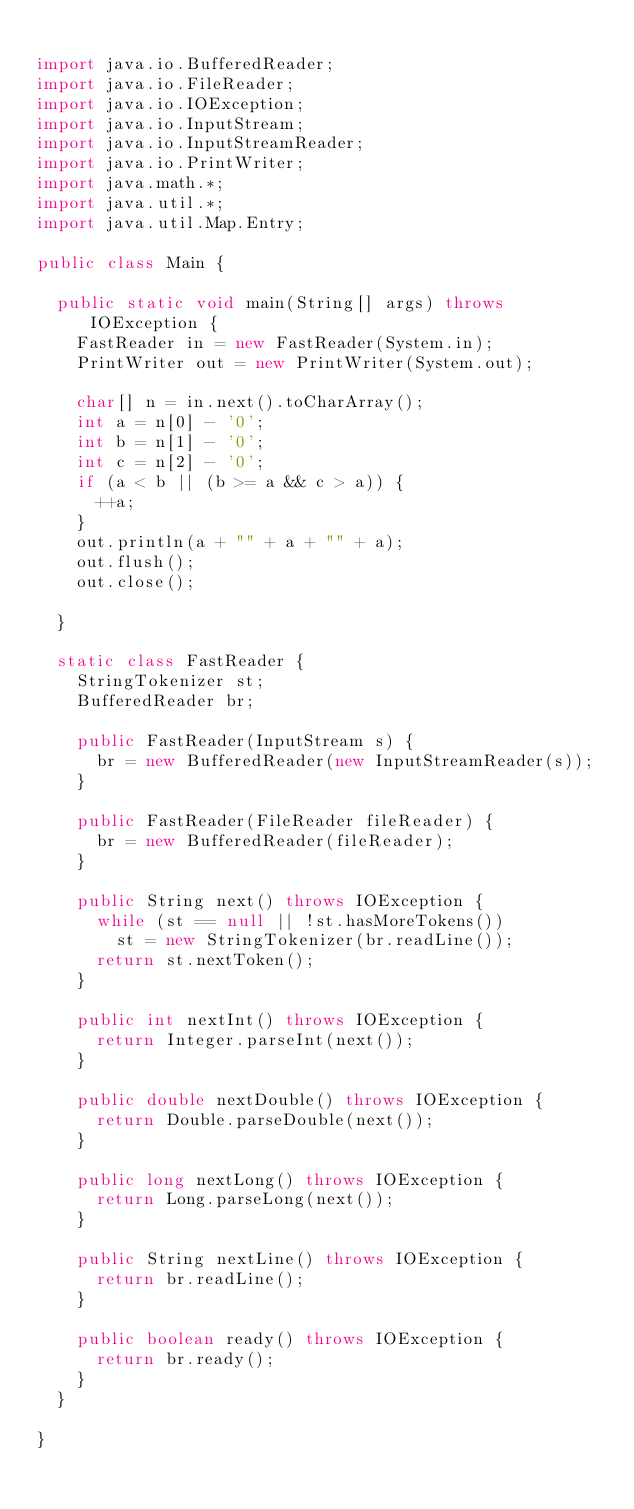Convert code to text. <code><loc_0><loc_0><loc_500><loc_500><_Java_>
import java.io.BufferedReader;
import java.io.FileReader;
import java.io.IOException;
import java.io.InputStream;
import java.io.InputStreamReader;
import java.io.PrintWriter;
import java.math.*;
import java.util.*;
import java.util.Map.Entry;

public class Main {

	public static void main(String[] args) throws IOException {
		FastReader in = new FastReader(System.in);
		PrintWriter out = new PrintWriter(System.out);

		char[] n = in.next().toCharArray();
		int a = n[0] - '0';
		int b = n[1] - '0';
		int c = n[2] - '0';
		if (a < b || (b >= a && c > a)) {
			++a;
		}
		out.println(a + "" + a + "" + a);
		out.flush();
		out.close();

	}

	static class FastReader {
		StringTokenizer st;
		BufferedReader br;

		public FastReader(InputStream s) {
			br = new BufferedReader(new InputStreamReader(s));
		}

		public FastReader(FileReader fileReader) {
			br = new BufferedReader(fileReader);
		}

		public String next() throws IOException {
			while (st == null || !st.hasMoreTokens())
				st = new StringTokenizer(br.readLine());
			return st.nextToken();
		}

		public int nextInt() throws IOException {
			return Integer.parseInt(next());
		}

		public double nextDouble() throws IOException {
			return Double.parseDouble(next());
		}

		public long nextLong() throws IOException {
			return Long.parseLong(next());
		}

		public String nextLine() throws IOException {
			return br.readLine();
		}

		public boolean ready() throws IOException {
			return br.ready();
		}
	}

}</code> 